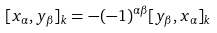Convert formula to latex. <formula><loc_0><loc_0><loc_500><loc_500>[ x _ { \alpha } , y _ { \beta } ] _ { k } = - ( - 1 ) ^ { \alpha \beta } [ y _ { \beta } , x _ { \alpha } ] _ { k }</formula> 